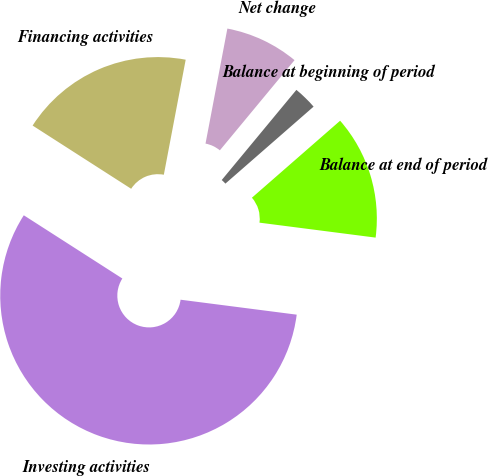Convert chart. <chart><loc_0><loc_0><loc_500><loc_500><pie_chart><fcel>Investing activities<fcel>Financing activities<fcel>Net change<fcel>Balance at beginning of period<fcel>Balance at end of period<nl><fcel>57.04%<fcel>18.91%<fcel>8.02%<fcel>2.57%<fcel>13.46%<nl></chart> 